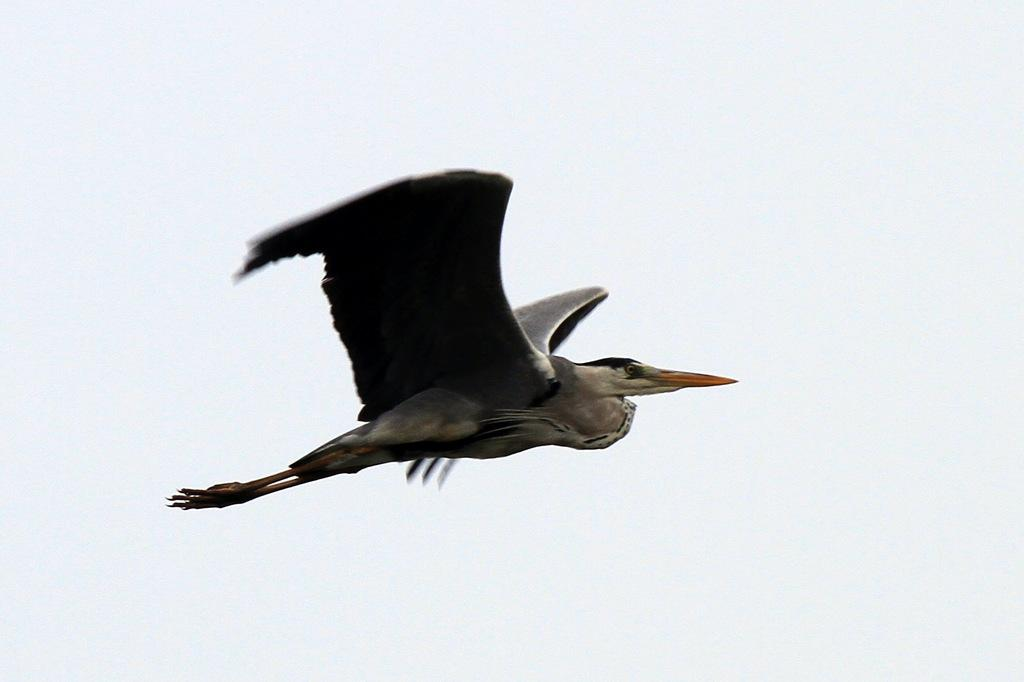What is the main subject of the image? There is a bird in the image. What is the bird doing in the image? The bird is flying. Where is the bird located in the image? The bird is in the center of the image. What type of advertisement is the bird promoting in the image? There is no advertisement present in the image; it simply features a bird flying. Is the bird a slave in the image? The concept of slavery does not apply to the bird in the image, as it is a living creature and not a human being. 